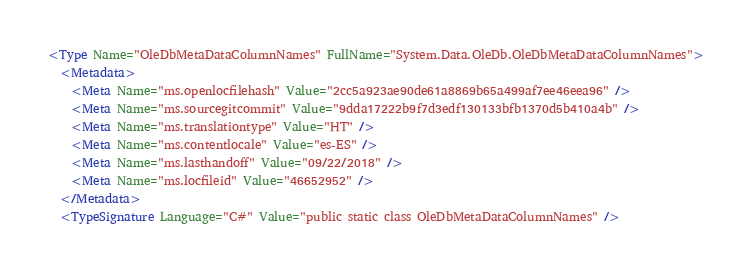Convert code to text. <code><loc_0><loc_0><loc_500><loc_500><_XML_><Type Name="OleDbMetaDataColumnNames" FullName="System.Data.OleDb.OleDbMetaDataColumnNames">
  <Metadata>
    <Meta Name="ms.openlocfilehash" Value="2cc5a923ae90de61a8869b65a499af7ee46eea96" />
    <Meta Name="ms.sourcegitcommit" Value="9dda17222b9f7d3edf130133bfb1370d5b410a4b" />
    <Meta Name="ms.translationtype" Value="HT" />
    <Meta Name="ms.contentlocale" Value="es-ES" />
    <Meta Name="ms.lasthandoff" Value="09/22/2018" />
    <Meta Name="ms.locfileid" Value="46652952" />
  </Metadata>
  <TypeSignature Language="C#" Value="public static class OleDbMetaDataColumnNames" /></code> 